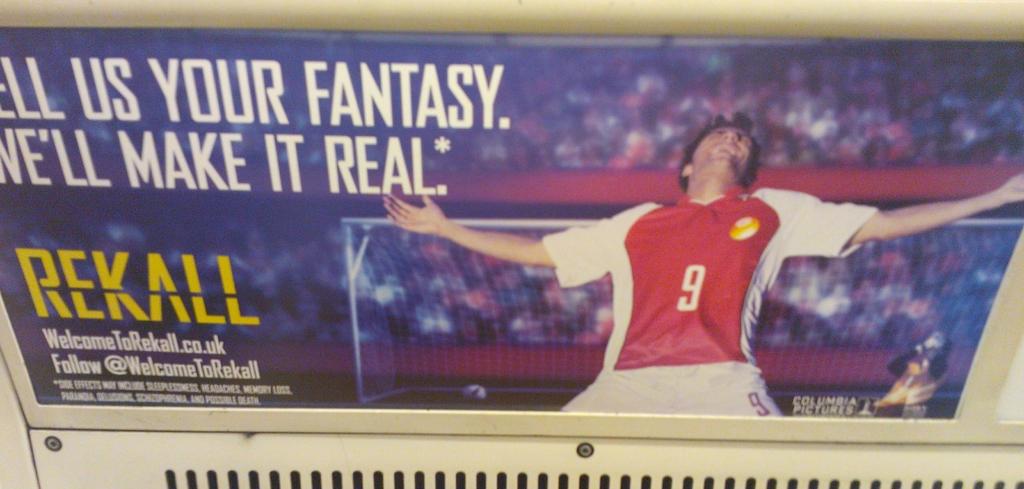What is the twitter handle?
Keep it short and to the point. @welcometorekall. 